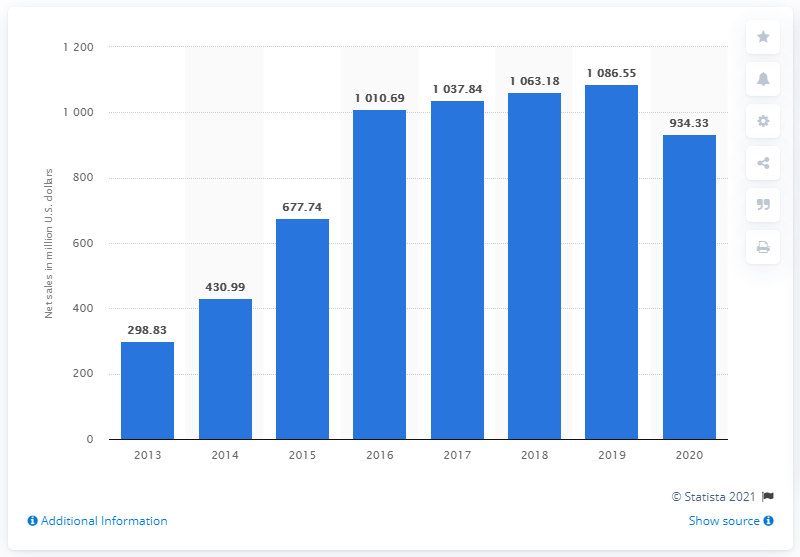Indicate a few pertinent items in this graphic. In 2020, Under Armour generated $934.33 million in footwear sales. 